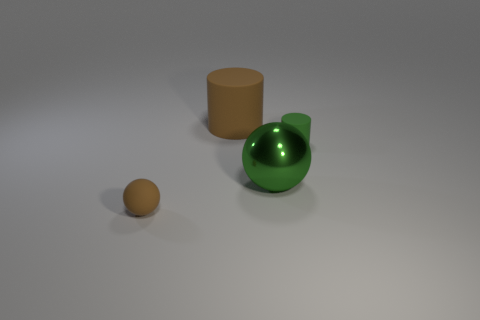Subtract 1 cylinders. How many cylinders are left? 1 Subtract all green cylinders. How many cylinders are left? 1 Add 1 metallic cylinders. How many objects exist? 5 Subtract all red spheres. How many green cylinders are left? 1 Subtract all green cylinders. Subtract all green balls. How many cylinders are left? 1 Subtract all green metallic things. Subtract all brown cylinders. How many objects are left? 2 Add 1 green things. How many green things are left? 3 Add 2 brown balls. How many brown balls exist? 3 Subtract 1 brown spheres. How many objects are left? 3 